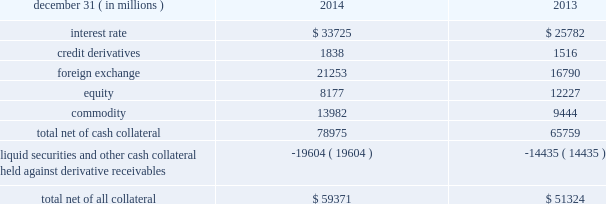Jpmorgan chase & co./2014 annual report 125 lending-related commitments the firm uses lending-related financial instruments , such as commitments ( including revolving credit facilities ) and guarantees , to meet the financing needs of its customers .
The contractual amounts of these financial instruments represent the maximum possible credit risk should the counterparties draw down on these commitments or the firm fulfills its obligations under these guarantees , and the counterparties subsequently fail to perform according to the terms of these contracts .
In the firm 2019s view , the total contractual amount of these wholesale lending-related commitments is not representative of the firm 2019s actual future credit exposure or funding requirements .
In determining the amount of credit risk exposure the firm has to wholesale lending-related commitments , which is used as the basis for allocating credit risk capital to these commitments , the firm has established a 201cloan-equivalent 201d amount for each commitment ; this amount represents the portion of the unused commitment or other contingent exposure that is expected , based on average portfolio historical experience , to become drawn upon in an event of a default by an obligor .
The loan-equivalent amount of the firm 2019s lending- related commitments was $ 229.6 billion and $ 218.9 billion as of december 31 , 2014 and 2013 , respectively .
Clearing services the firm provides clearing services for clients entering into securities and derivative transactions .
Through the provision of these services the firm is exposed to the risk of non-performance by its clients and may be required to share in losses incurred by central counterparties ( 201cccps 201d ) .
Where possible , the firm seeks to mitigate its credit risk to its clients through the collection of adequate margin at inception and throughout the life of the transactions and can also cease provision of clearing services if clients do not adhere to their obligations under the clearing agreement .
For further discussion of clearing services , see note 29 .
Derivative contracts in the normal course of business , the firm uses derivative instruments predominantly for market-making activities .
Derivatives enable customers to manage exposures to fluctuations in interest rates , currencies and other markets .
The firm also uses derivative instruments to manage its own credit exposure .
The nature of the counterparty and the settlement mechanism of the derivative affect the credit risk to which the firm is exposed .
For otc derivatives the firm is exposed to the credit risk of the derivative counterparty .
For exchange-traded derivatives ( 201cetd 201d ) such as futures and options , and 201ccleared 201d over-the-counter ( 201cotc-cleared 201d ) derivatives , the firm is generally exposed to the credit risk of the relevant ccp .
Where possible , the firm seeks to mitigate its credit risk exposures arising from derivative transactions through the use of legally enforceable master netting arrangements and collateral agreements .
For further discussion of derivative contracts , counterparties and settlement types , see note 6 .
The table summarizes the net derivative receivables for the periods presented .
Derivative receivables .
Derivative receivables reported on the consolidated balance sheets were $ 79.0 billion and $ 65.8 billion at december 31 , 2014 and 2013 , respectively .
These amounts represent the fair value of the derivative contracts , after giving effect to legally enforceable master netting agreements and cash collateral held by the firm .
However , in management 2019s view , the appropriate measure of current credit risk should also take into consideration additional liquid securities ( primarily u.s .
Government and agency securities and other g7 government bonds ) and other cash collateral held by the firm aggregating $ 19.6 billion and $ 14.4 billion at december 31 , 2014 and 2013 , respectively , that may be used as security when the fair value of the client 2019s exposure is in the firm 2019s favor .
In addition to the collateral described in the preceding paragraph , the firm also holds additional collateral ( primarily : cash ; g7 government securities ; other liquid government-agency and guaranteed securities ; and corporate debt and equity securities ) delivered by clients at the initiation of transactions , as well as collateral related to contracts that have a non-daily call frequency and collateral that the firm has agreed to return but has not yet settled as of the reporting date .
Although this collateral does not reduce the balances and is not included in the table above , it is available as security against potential exposure that could arise should the fair value of the client 2019s derivative transactions move in the firm 2019s favor .
As of december 31 , 2014 and 2013 , the firm held $ 48.6 billion and $ 50.8 billion , respectively , of this additional collateral .
The prior period amount has been revised to conform with the current period presentation .
The derivative receivables fair value , net of all collateral , also does not include other credit enhancements , such as letters of credit .
For additional information on the firm 2019s use of collateral agreements , see note 6. .
What percent of net derivative receivables were collateralized by other than cash in 2014?\\n? 
Computations: (19604 / 78975)
Answer: 0.24823. 